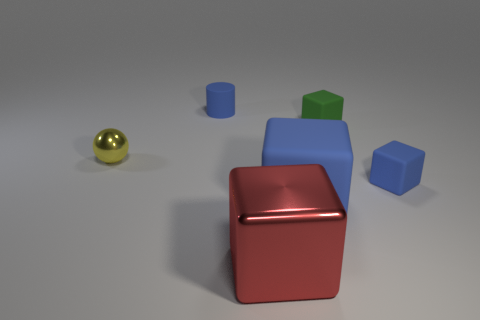Subtract all blue cubes. How many were subtracted if there are1blue cubes left? 1 Subtract all blue cubes. Subtract all cyan spheres. How many cubes are left? 2 Add 3 small blue rubber cylinders. How many objects exist? 9 Subtract all blocks. How many objects are left? 2 Add 4 tiny green matte cubes. How many tiny green matte cubes are left? 5 Add 1 blue matte cylinders. How many blue matte cylinders exist? 2 Subtract 0 purple cylinders. How many objects are left? 6 Subtract all blue matte cylinders. Subtract all small cylinders. How many objects are left? 4 